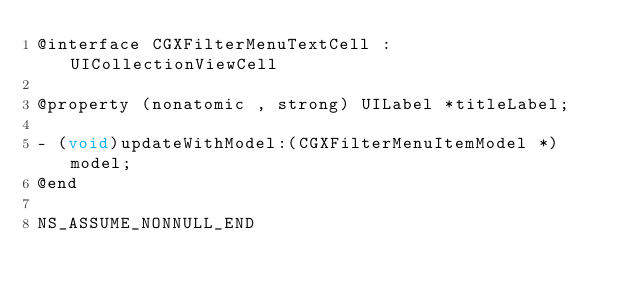<code> <loc_0><loc_0><loc_500><loc_500><_C_>@interface CGXFilterMenuTextCell : UICollectionViewCell

@property (nonatomic , strong) UILabel *titleLabel;

- (void)updateWithModel:(CGXFilterMenuItemModel *)model;
@end

NS_ASSUME_NONNULL_END
</code> 